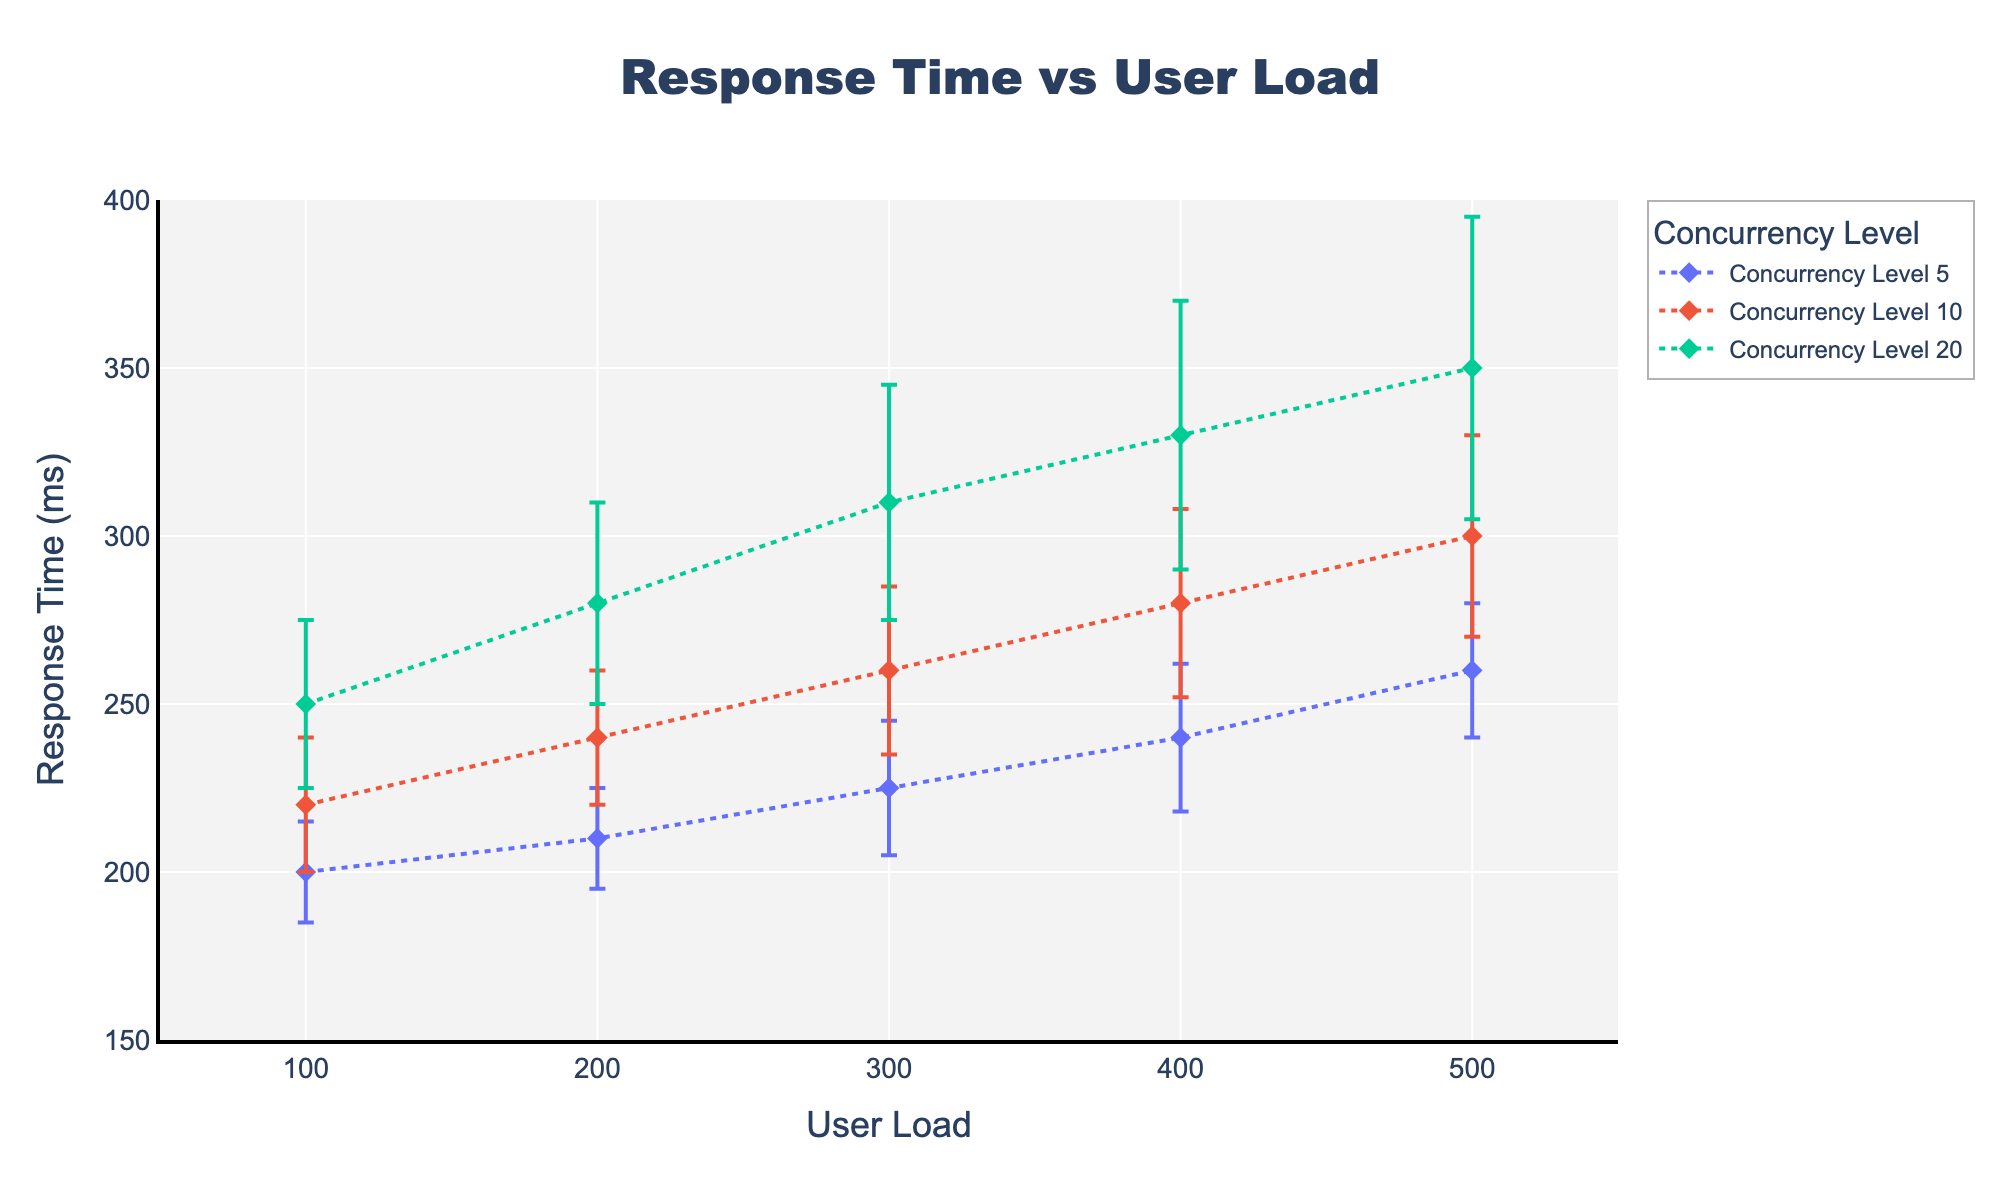What's the title of the plot? The title is located at the top center of the plot and reads "Response Time vs User Load".
Answer: Response Time vs User Load What is the range of the y-axis? The y-axis range is determined by the axis labels. The plot ranges from 150 to 400 ms.
Answer: 150 to 400 ms Which concurrency level shows the highest response time at a user load of 300? For a user load of 300, the highest response time can be identified by comparing the y-values of the lines. The highest response time at this user load is found for Concurrency Level 20, which has a response time of 310 ms.
Answer: Concurrency Level 20 How does the response time change as the user load increases for Concurrency Level 10? By observing the line for Concurrency Level 10, it can be seen that the response time increases as the user load increases from 100 to 500.
Answer: It increases What is the difference in response time between concurrency levels 5 and 20 at a user load of 200? The response time for Concurrency Level 5 at a user load of 200 is 210 ms, and for Concurrency Level 20, it is 280 ms. The difference is 280 - 210 = 70 ms.
Answer: 70 ms Which concurrency level has the smallest increase in response time from user load 100 to 200? To determine this, calculate the difference in response time for each concurrency level between user load 100 and 200. Concurrency Level 5 goes from 200 to 210 (10 ms increase), Concurrency Level 10 goes from 220 to 240 (20 ms increase), and Concurrency Level 20 goes from 250 to 280 (30 ms increase). The smallest increase is for Concurrency Level 5.
Answer: Concurrency Level 5 What is the average response time for Concurrency Level 5 across all user loads? Combine the response times for Concurrency Level 5: 200, 210, 225, 240, 260. Their sum is 1135. The average is 1135/5 = 227 ms.
Answer: 227 ms For which user load is the error margin highest for Concurrency Level 20? The error margins for Concurrency Level 20 at various user loads are: 25, 30, 35, 40, 45. The highest error margin is at user load 500, where the error is 45.
Answer: User load 500 Is the trend in response time consistent across different concurrency levels? Observing the lines, each concurrency level shows an increasing trend in response time with increasing user load, indicating consistency across levels.
Answer: Yes What's the range of x-axis on the plot? The range of the x-axis can be identified by looking at the axis labels. The plot ranges from 50 to 550 user loads.
Answer: 50 to 550 